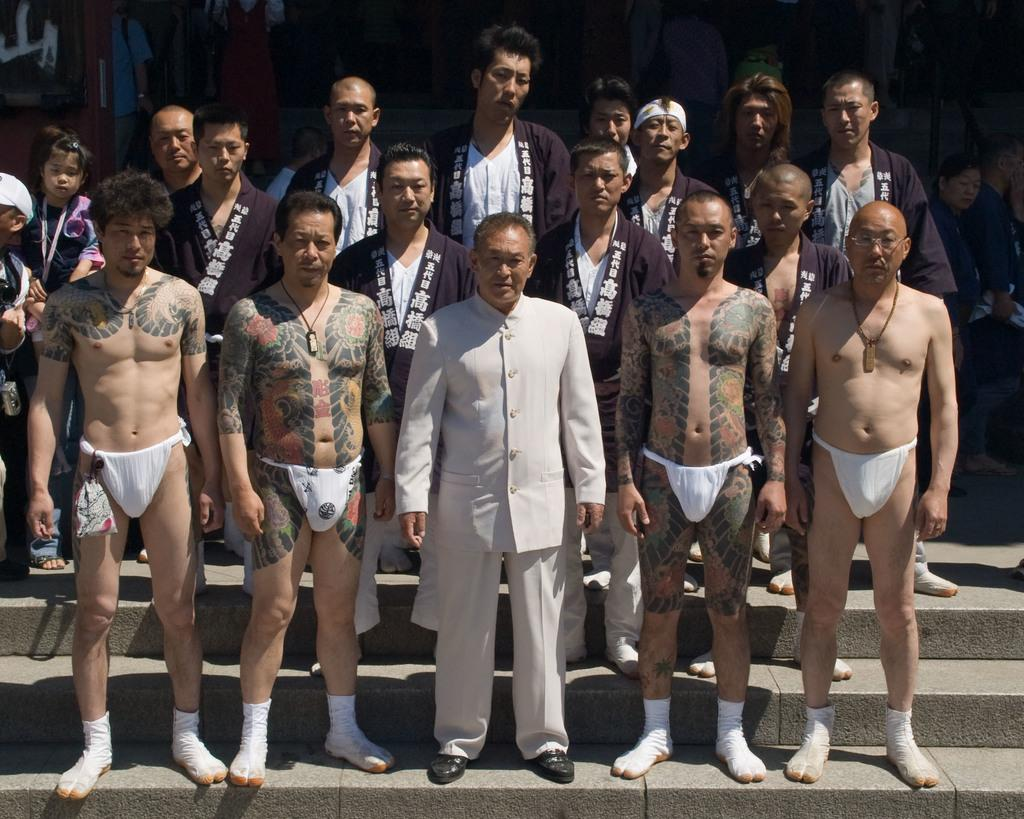How many individuals are present in the image? There are many people in the image. Can you describe any objects visible at the top of the image? Unfortunately, the provided facts do not give any information about the objects at the top of the image. What type of butter is being used by the uncle in the image? There is no uncle or butter present in the image. 